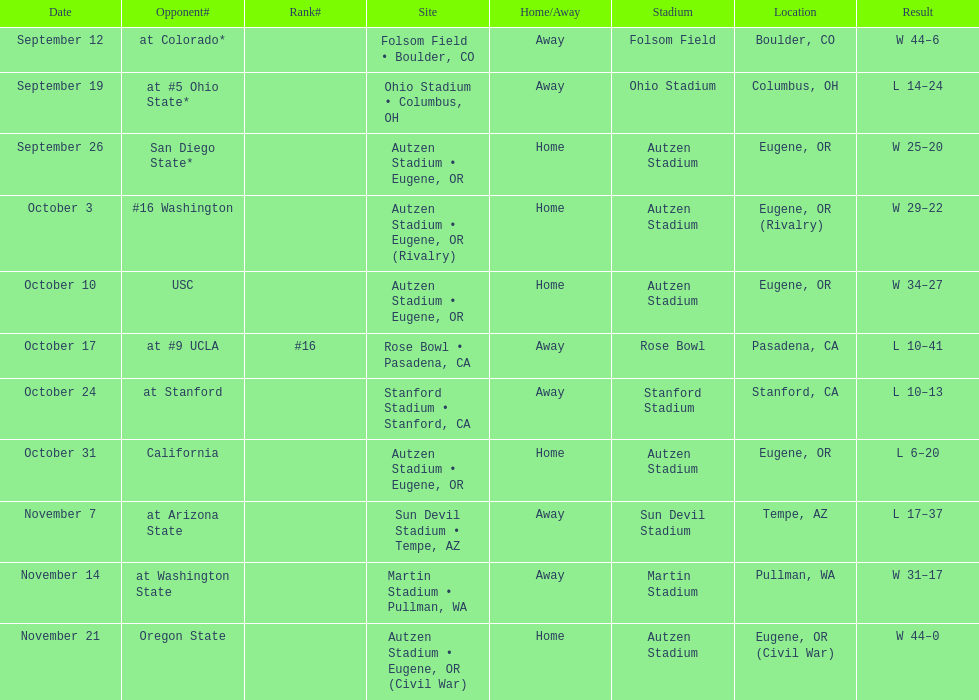How many games did the team win while not at home? 2. 